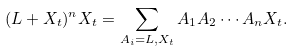Convert formula to latex. <formula><loc_0><loc_0><loc_500><loc_500>( L + X _ { t } ) ^ { n } X _ { t } = \sum _ { A _ { i } = L , X _ { t } } A _ { 1 } A _ { 2 } \cdots A _ { n } X _ { t } .</formula> 